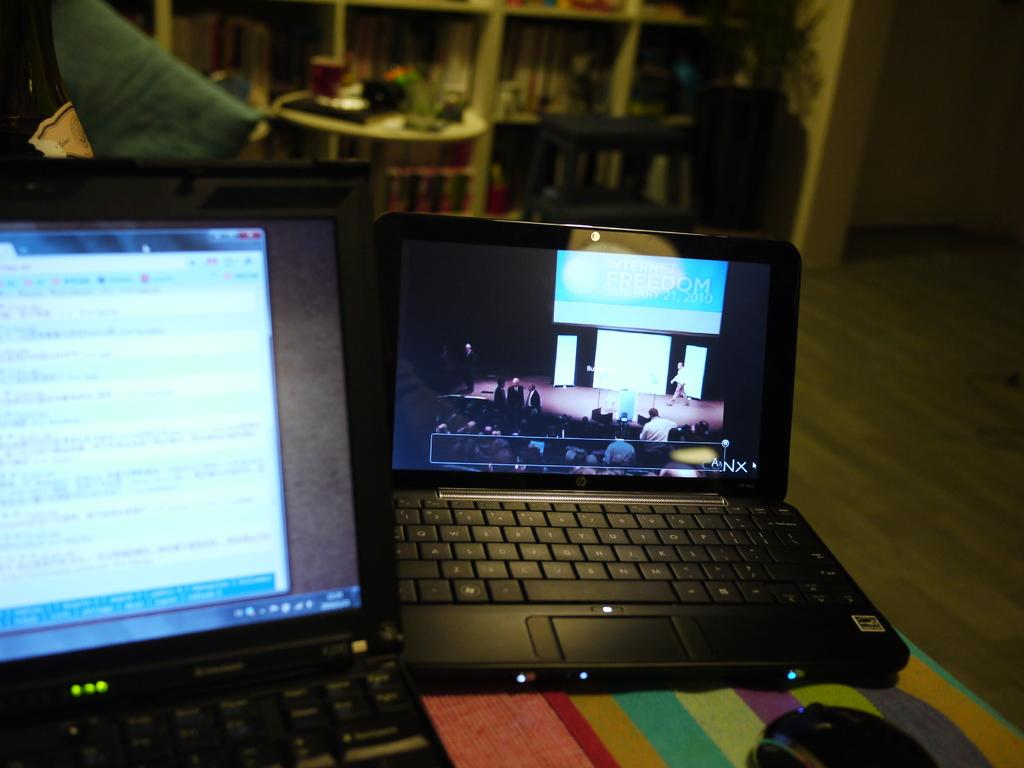<image>
Relay a brief, clear account of the picture shown. Internet Freedom Jan. 21 2010 is the header of this laptop page. 